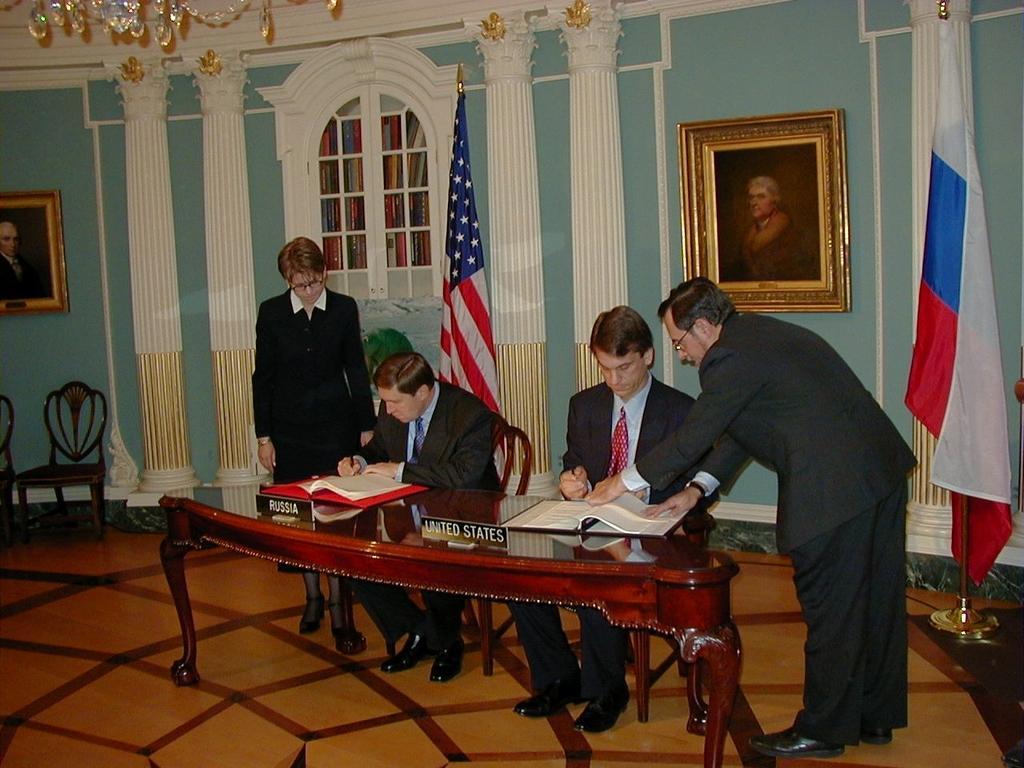Could you give a brief overview of what you see in this image? This picture is a man sitting and writing in notebook with another man sitting and reading it. There is a man standing beside the person who is reading and the woman standing beside the person who is writing. There is a flag in the backdrop, a bookshelf, there is a photo frame on the wall and the floor is brown colour there are some chairs to sit. 